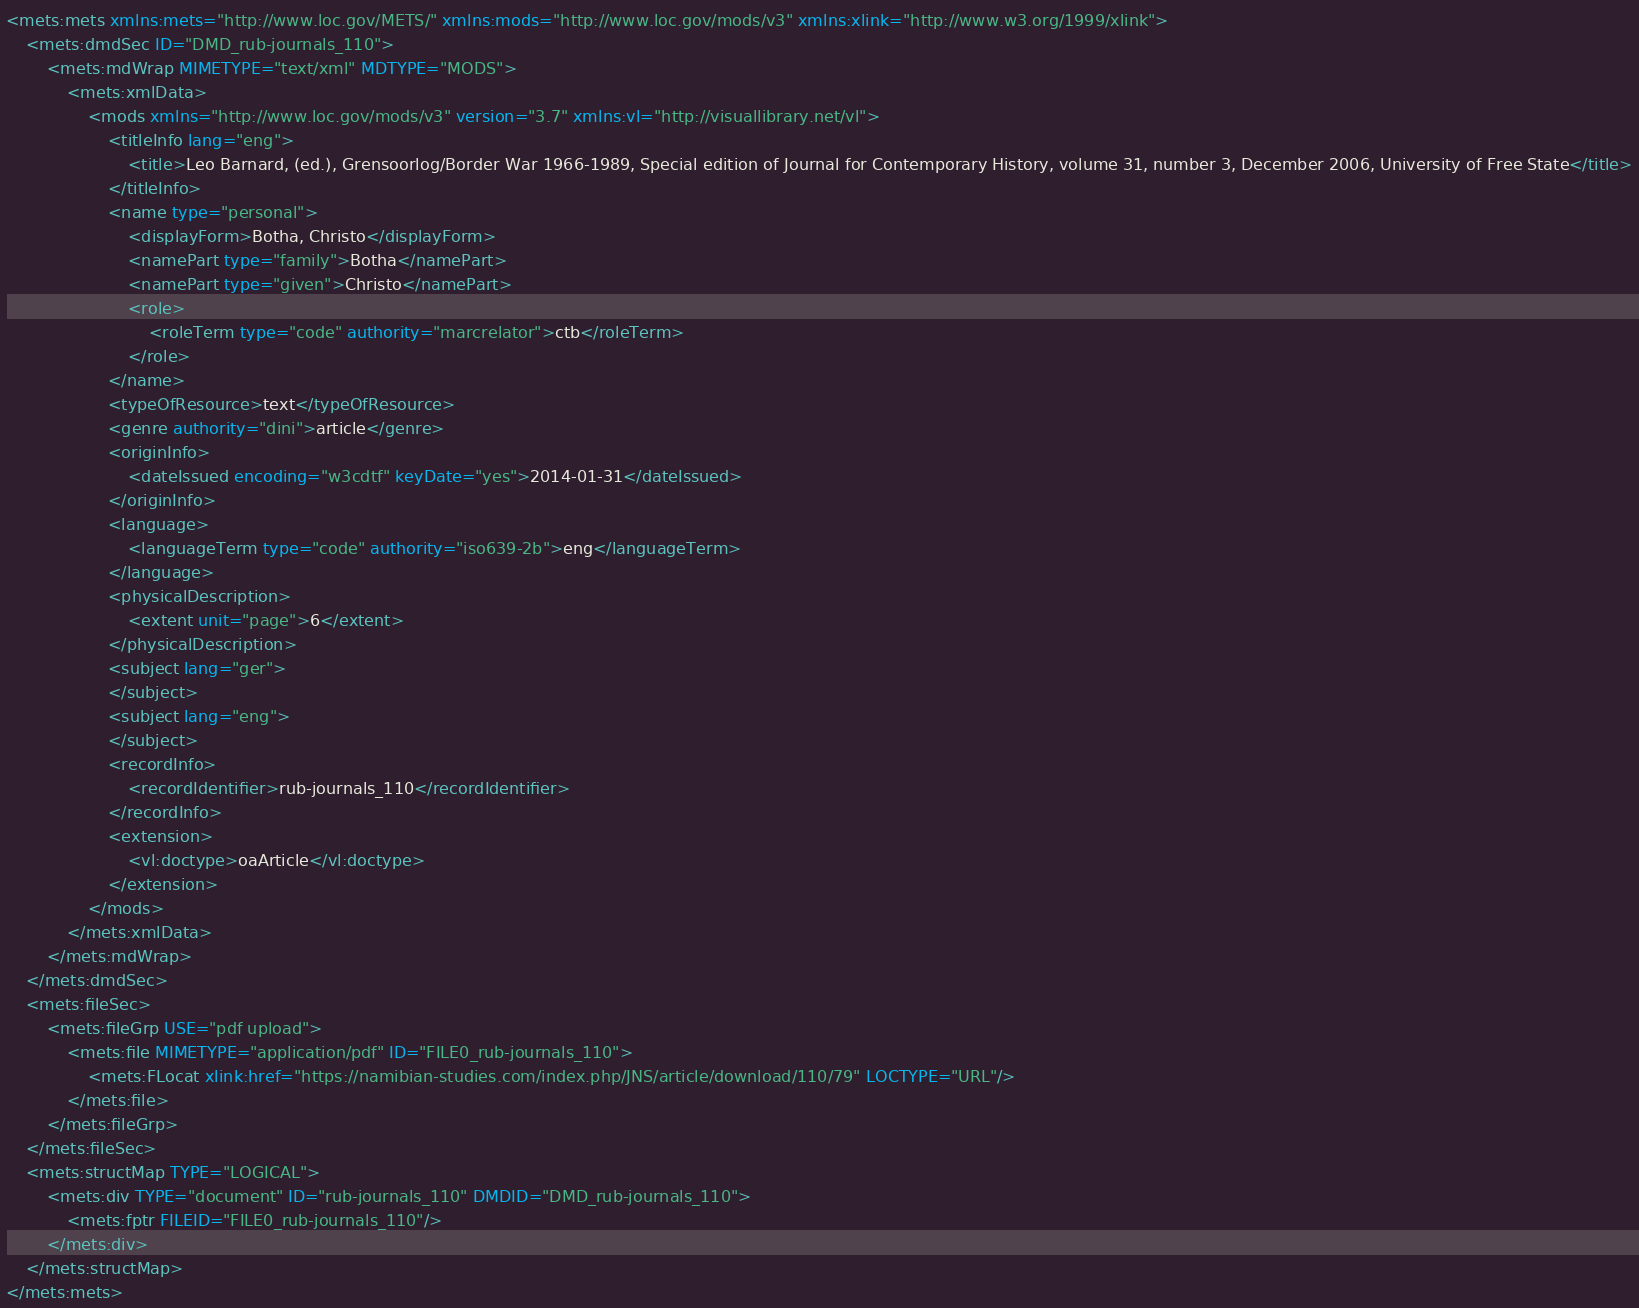<code> <loc_0><loc_0><loc_500><loc_500><_XML_><mets:mets xmlns:mets="http://www.loc.gov/METS/" xmlns:mods="http://www.loc.gov/mods/v3" xmlns:xlink="http://www.w3.org/1999/xlink">
    <mets:dmdSec ID="DMD_rub-journals_110">
        <mets:mdWrap MIMETYPE="text/xml" MDTYPE="MODS">
            <mets:xmlData>
                <mods xmlns="http://www.loc.gov/mods/v3" version="3.7" xmlns:vl="http://visuallibrary.net/vl">
                    <titleInfo lang="eng">
                        <title>Leo Barnard, (ed.), Grens­oorlog/Border War 1966-1989, Special edition of Journal for Contemporary History, volume 31, number 3, December 2006, University of Free State</title>
                    </titleInfo>
                    <name type="personal">
                        <displayForm>Botha, Christo</displayForm>
                        <namePart type="family">Botha</namePart>
                        <namePart type="given">Christo</namePart>
                        <role>
                            <roleTerm type="code" authority="marcrelator">ctb</roleTerm>
                        </role>
                    </name>
                    <typeOfResource>text</typeOfResource>
                    <genre authority="dini">article</genre>
                    <originInfo>
                        <dateIssued encoding="w3cdtf" keyDate="yes">2014-01-31</dateIssued>
                    </originInfo>
                    <language>
                        <languageTerm type="code" authority="iso639-2b">eng</languageTerm>
                    </language>
                    <physicalDescription>
                        <extent unit="page">6</extent>
                    </physicalDescription>
                    <subject lang="ger">
                    </subject>
                    <subject lang="eng">
                    </subject>
                    <recordInfo>
                        <recordIdentifier>rub-journals_110</recordIdentifier>
                    </recordInfo>
                    <extension>
                        <vl:doctype>oaArticle</vl:doctype>
                    </extension>
                </mods>
            </mets:xmlData>
        </mets:mdWrap>
    </mets:dmdSec>
    <mets:fileSec>
        <mets:fileGrp USE="pdf upload">
            <mets:file MIMETYPE="application/pdf" ID="FILE0_rub-journals_110">
                <mets:FLocat xlink:href="https://namibian-studies.com/index.php/JNS/article/download/110/79" LOCTYPE="URL"/>
            </mets:file>
        </mets:fileGrp>
    </mets:fileSec>
    <mets:structMap TYPE="LOGICAL">
        <mets:div TYPE="document" ID="rub-journals_110" DMDID="DMD_rub-journals_110">
            <mets:fptr FILEID="FILE0_rub-journals_110"/>
        </mets:div>
    </mets:structMap>
</mets:mets>
</code> 